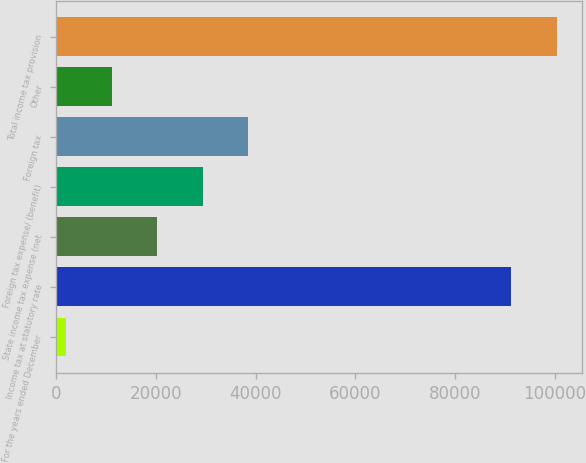<chart> <loc_0><loc_0><loc_500><loc_500><bar_chart><fcel>For the years ended December<fcel>Income tax at statutory rate<fcel>State income tax expense (net<fcel>Foreign tax expense/ (benefit)<fcel>Foreign tax<fcel>Other<fcel>Total income tax provision<nl><fcel>2016<fcel>91222<fcel>20266.2<fcel>29391.3<fcel>38516.4<fcel>11141.1<fcel>100347<nl></chart> 